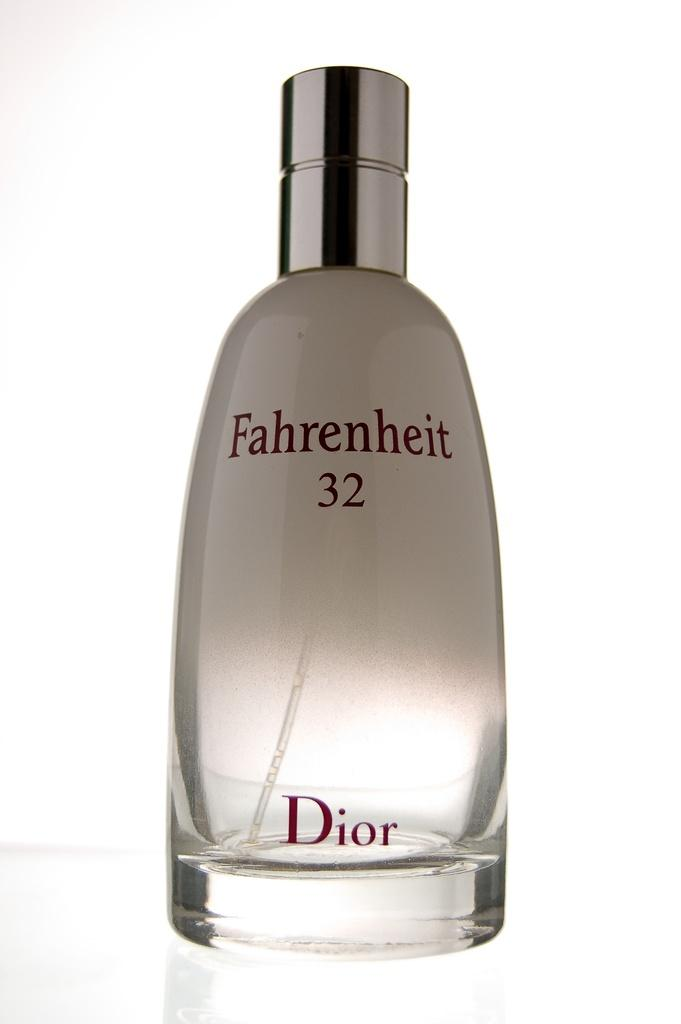<image>
Share a concise interpretation of the image provided. A silvery white bottle of Dior fragrance is named Fahrenheit 32. 